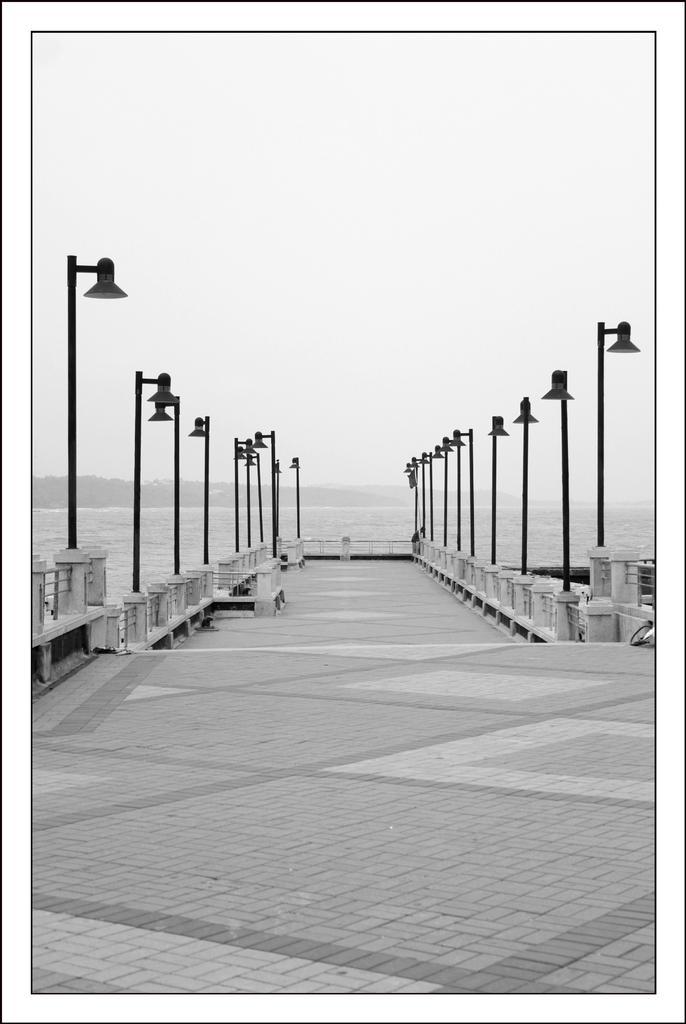In one or two sentences, can you explain what this image depicts? This is a black and white picture. In this picture we can see a few street lights on the right and left side of the path. We can see water and a few things in the background. 